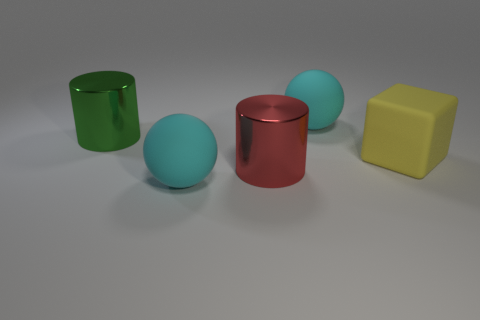Add 3 red metallic objects. How many objects exist? 8 Subtract all cylinders. How many objects are left? 3 Subtract 1 cylinders. How many cylinders are left? 1 Subtract all yellow rubber things. Subtract all tiny green metallic objects. How many objects are left? 4 Add 5 red metallic things. How many red metallic things are left? 6 Add 4 large red shiny things. How many large red shiny things exist? 5 Subtract 0 purple blocks. How many objects are left? 5 Subtract all gray spheres. Subtract all yellow cubes. How many spheres are left? 2 